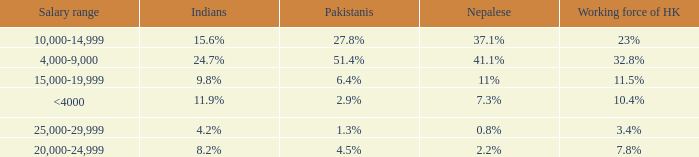If the working force of HK is 32.8%, what are the Pakistanis' %?  51.4%. 